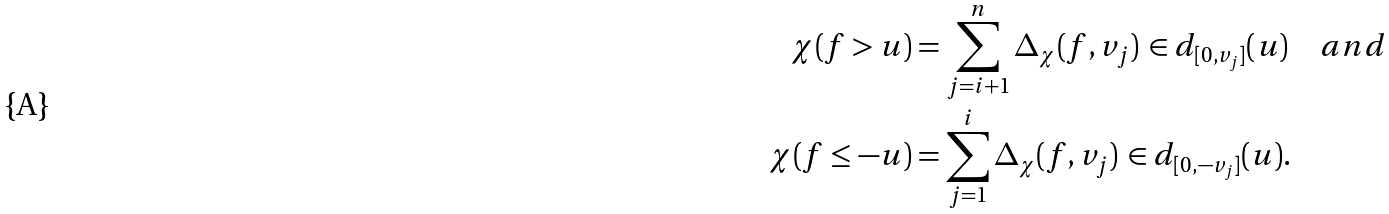Convert formula to latex. <formula><loc_0><loc_0><loc_500><loc_500>\chi ( f > u ) & = \sum _ { j = i + 1 } ^ { n } \Delta _ { \chi } ( f , v _ { j } ) \, \in d _ { [ 0 , v _ { j } ] } ( u ) \quad a n d \\ \chi ( f \leq - u ) & = \sum _ { j = 1 } ^ { i } \Delta _ { \chi } ( f , v _ { j } ) \, \in d _ { [ 0 , - v _ { j } ] } ( u ) .</formula> 